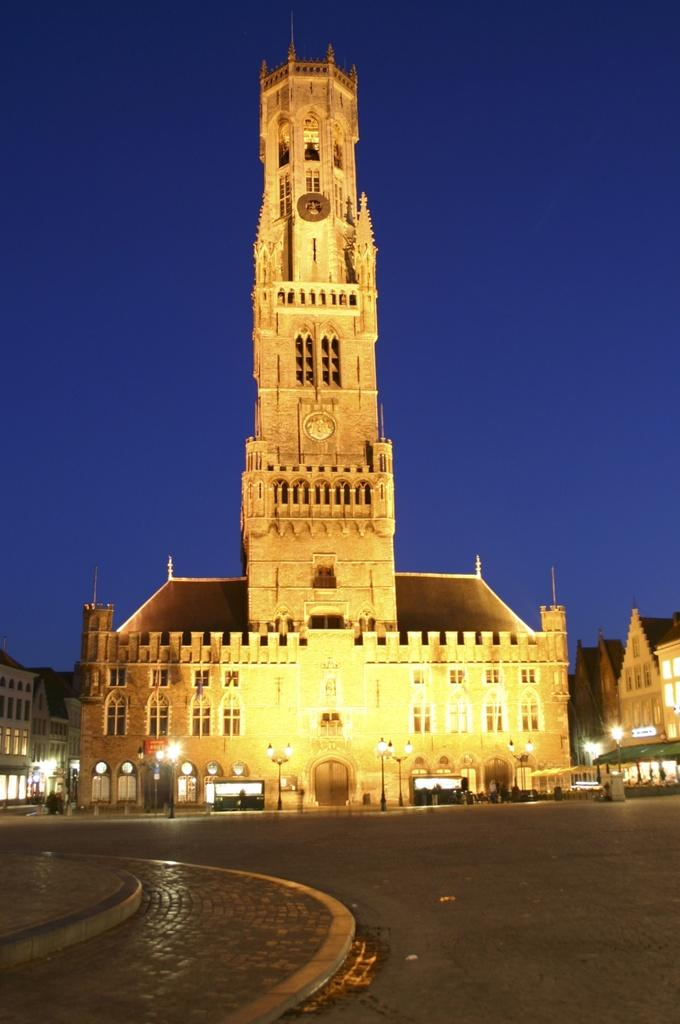What is the main feature of the image? There is a road in the image. What can be seen in the background of the image? There are street light poles, buildings with windows, and the sky visible in the background. What type of news can be heard coming from the buildings in the image? There is no indication in the image that any news is being broadcasted or heard from the buildings. 